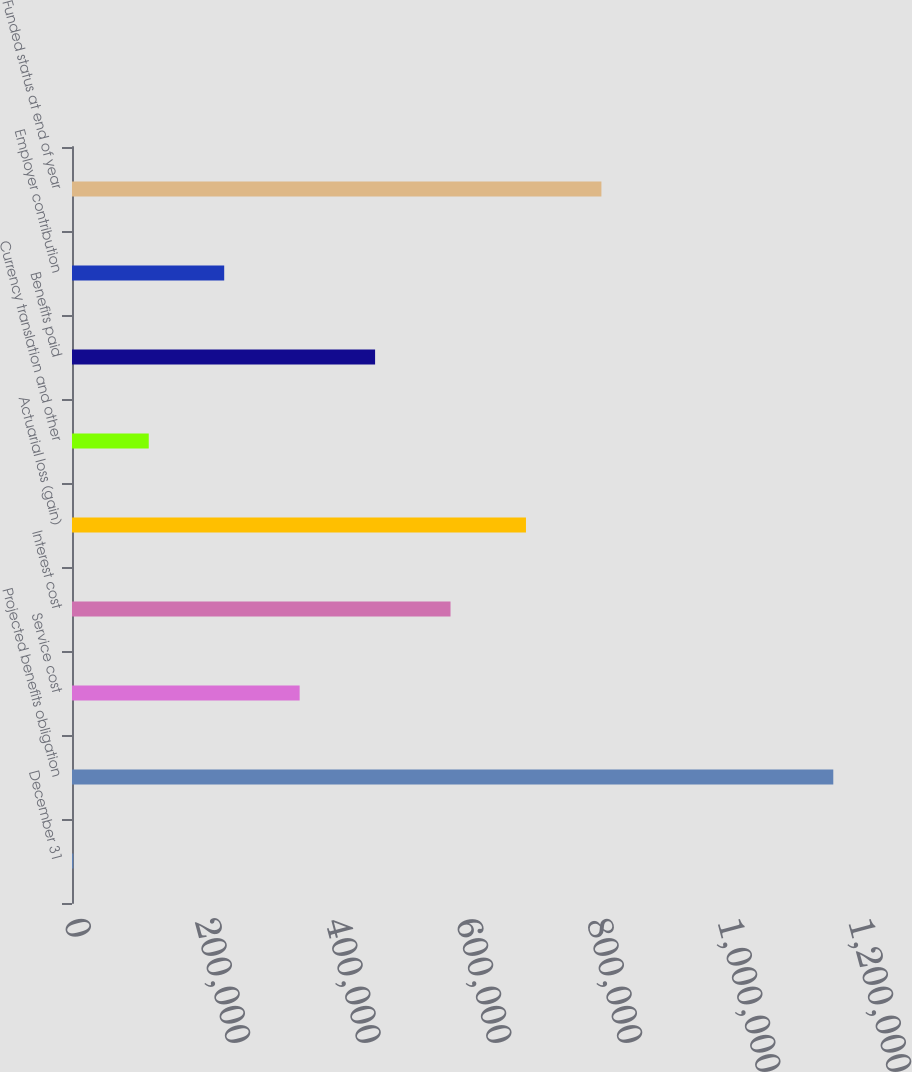<chart> <loc_0><loc_0><loc_500><loc_500><bar_chart><fcel>December 31<fcel>Projected benefits obligation<fcel>Service cost<fcel>Interest cost<fcel>Actuarial loss (gain)<fcel>Currency translation and other<fcel>Benefits paid<fcel>Employer contribution<fcel>Funded status at end of year<nl><fcel>2011<fcel>1.16524e+06<fcel>348434<fcel>579384<fcel>694858<fcel>117486<fcel>463909<fcel>232960<fcel>810332<nl></chart> 